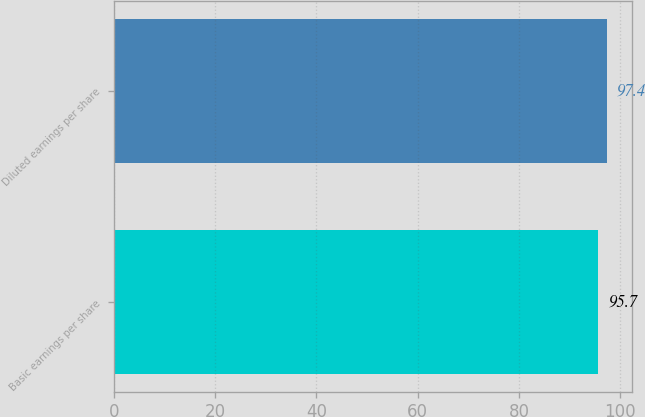Convert chart. <chart><loc_0><loc_0><loc_500><loc_500><bar_chart><fcel>Basic earnings per share<fcel>Diluted earnings per share<nl><fcel>95.7<fcel>97.4<nl></chart> 